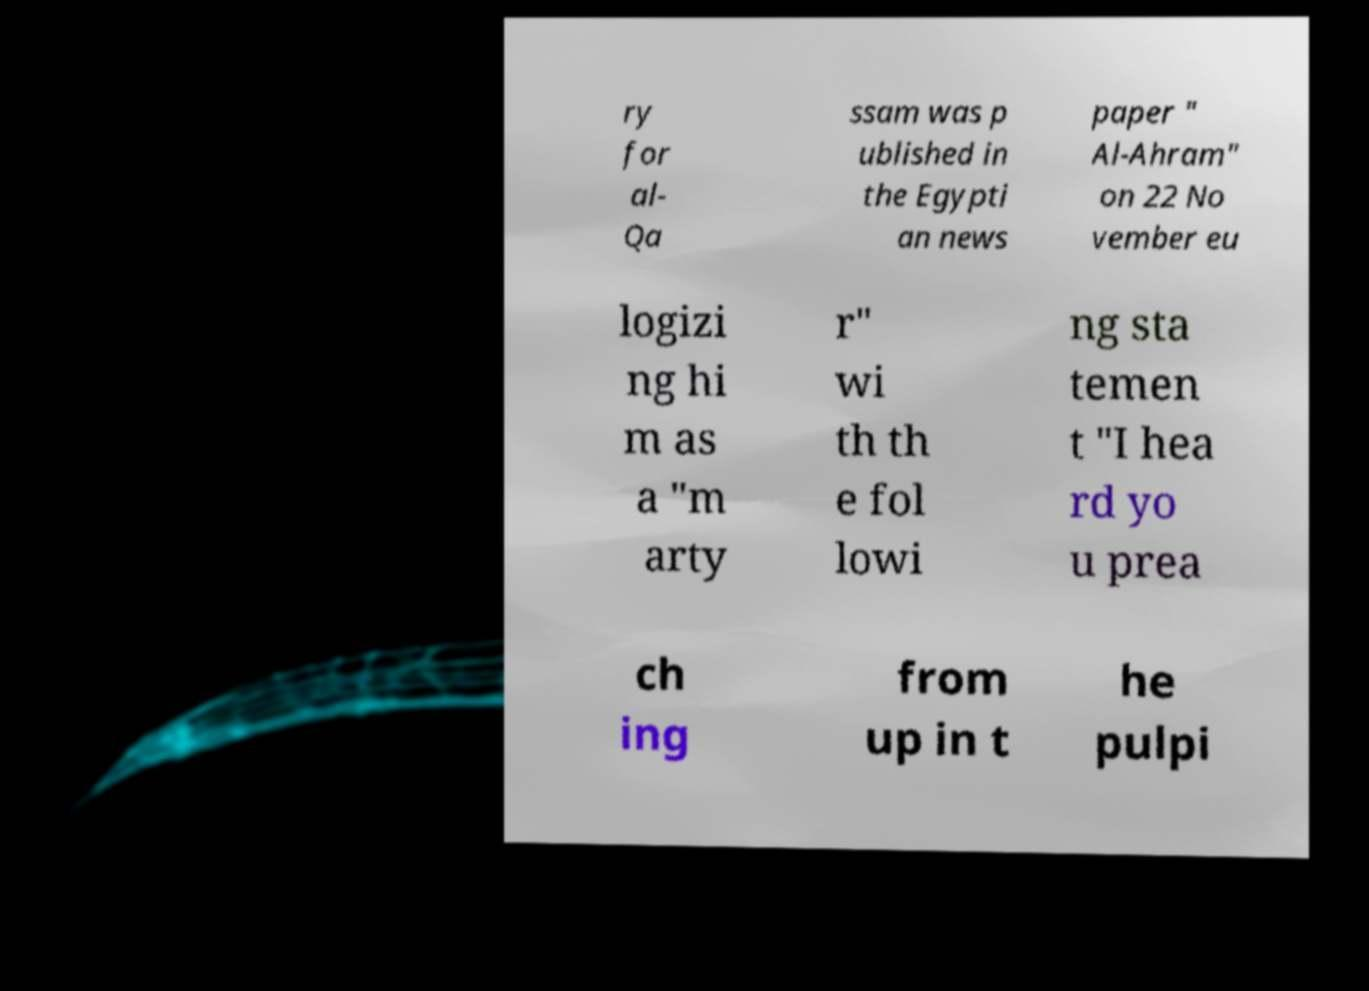Can you read and provide the text displayed in the image?This photo seems to have some interesting text. Can you extract and type it out for me? ry for al- Qa ssam was p ublished in the Egypti an news paper " Al-Ahram" on 22 No vember eu logizi ng hi m as a "m arty r" wi th th e fol lowi ng sta temen t "I hea rd yo u prea ch ing from up in t he pulpi 